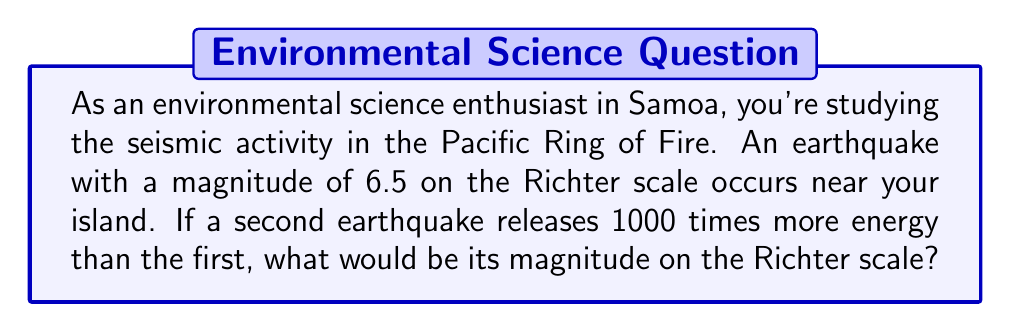Help me with this question. Let's approach this step-by-step:

1) The Richter scale is logarithmic, based on the equation:

   $$ M = \log_{10}\left(\frac{A}{A_0}\right) $$

   Where $M$ is the magnitude, $A$ is the amplitude of the seismic waves, and $A_0$ is a standard reference amplitude.

2) The energy released in an earthquake is proportional to the square of the amplitude. So, if we increase the energy by a factor of 1000, we increase the amplitude by a factor of $\sqrt{1000} = 10\sqrt{10}$.

3) Let $M_1 = 6.5$ be the magnitude of the first earthquake and $M_2$ be the magnitude of the second earthquake. We can write:

   $$ M_2 - M_1 = \log_{10}\left(\frac{A_2}{A_1}\right) $$

4) We know that $\frac{A_2}{A_1} = 10\sqrt{10}$, so:

   $$ M_2 - 6.5 = \log_{10}(10\sqrt{10}) $$

5) Simplify the right side:

   $$ M_2 - 6.5 = \log_{10}(10) + \log_{10}(\sqrt{10}) = 1 + \frac{1}{2}\log_{10}(10) = 1.5 $$

6) Solve for $M_2$:

   $$ M_2 = 6.5 + 1.5 = 8.0 $$

Therefore, the magnitude of the second earthquake would be 8.0 on the Richter scale.
Answer: 8.0 